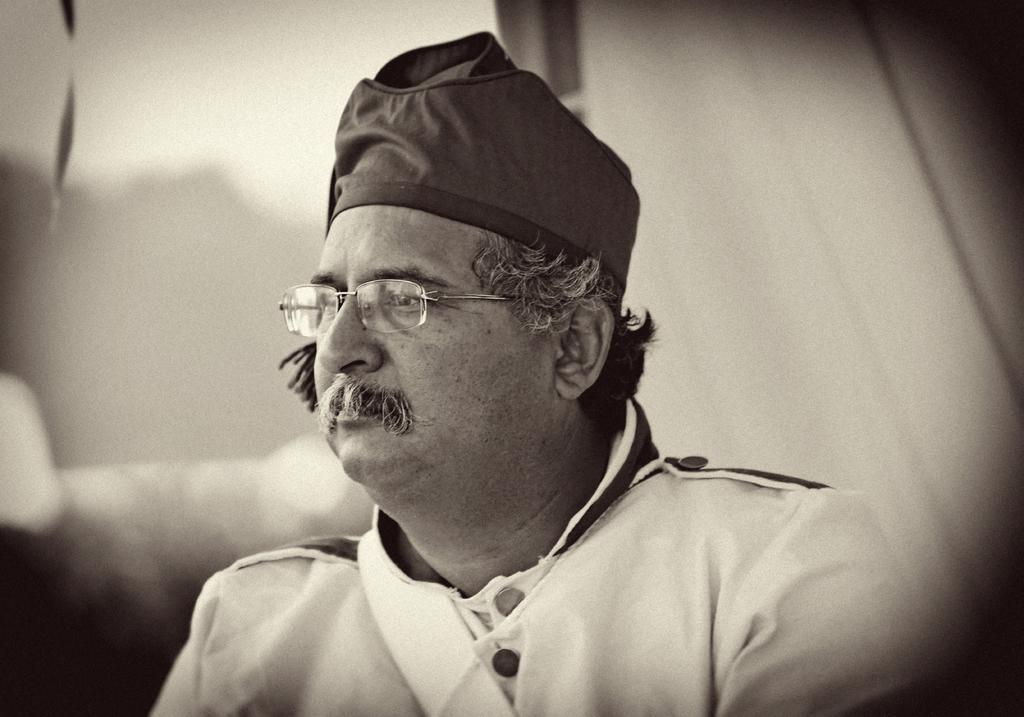Who is the main subject in the image? There is an old man in the image. What is the old man wearing on his head? The old man is wearing a cap. Where is the cap located on the old man? The cap is on the old man's head. What is the color scheme of the image? The image is black and white. What accessory is the old man wearing on his face? The old man is wearing glasses. Where are the glasses positioned on the old man's face? The glasses are over the old man's eyes. What type of brush is the old man using to paint in the image? There is no brush or painting activity present in the image. How many people are visible in the image? There is only one person visible in the image, which is the old man. 